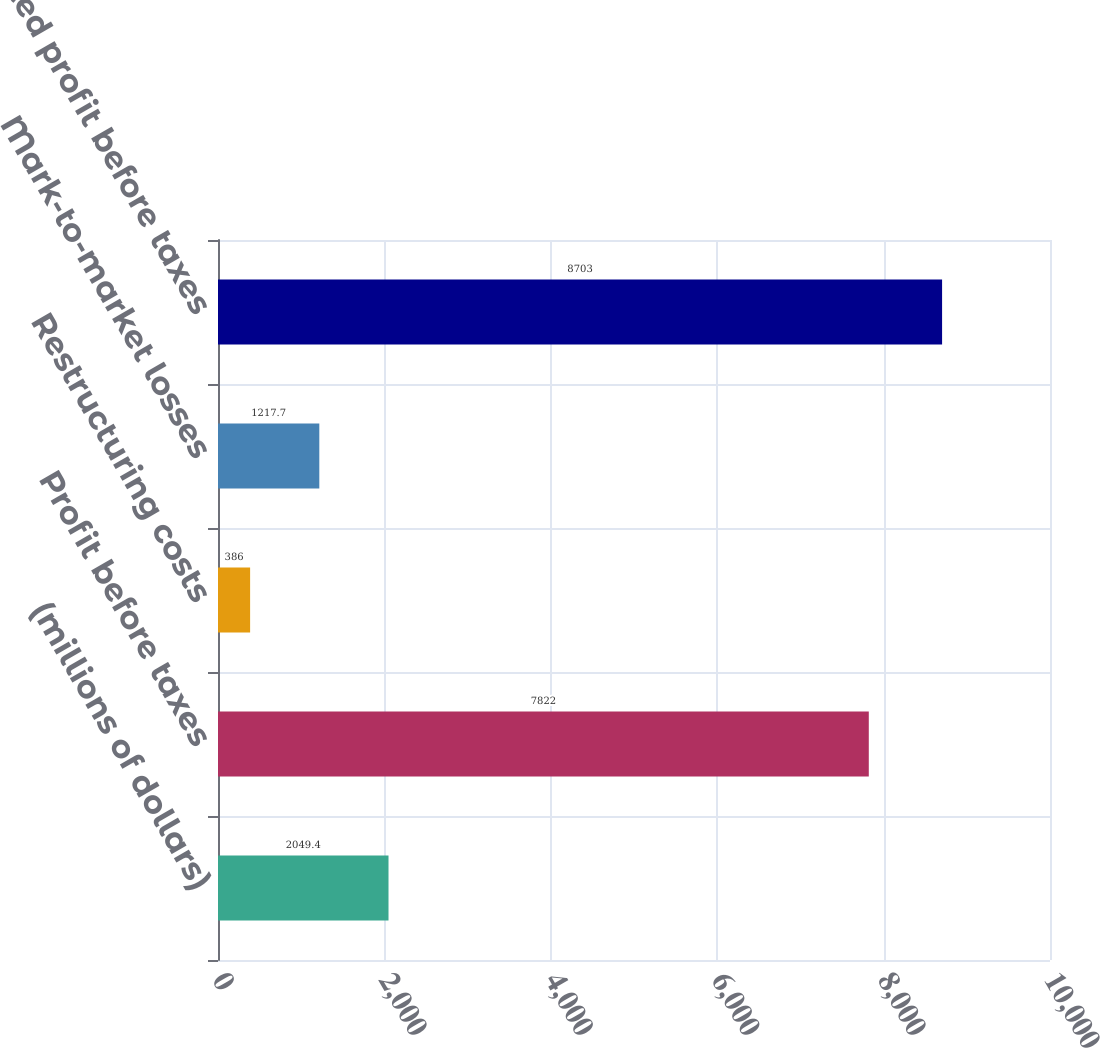Convert chart to OTSL. <chart><loc_0><loc_0><loc_500><loc_500><bar_chart><fcel>(millions of dollars)<fcel>Profit before taxes<fcel>Restructuring costs<fcel>Mark-to-market losses<fcel>Adjusted profit before taxes<nl><fcel>2049.4<fcel>7822<fcel>386<fcel>1217.7<fcel>8703<nl></chart> 